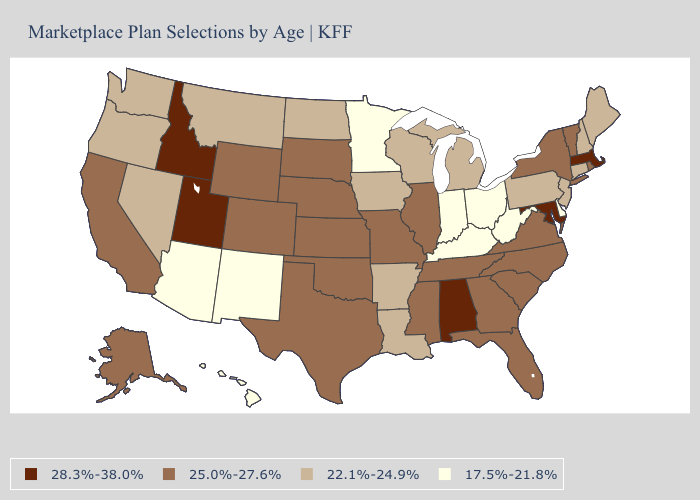Which states hav the highest value in the Northeast?
Write a very short answer. Massachusetts. Which states have the lowest value in the Northeast?
Give a very brief answer. Connecticut, Maine, New Hampshire, New Jersey, Pennsylvania. Name the states that have a value in the range 22.1%-24.9%?
Quick response, please. Arkansas, Connecticut, Iowa, Louisiana, Maine, Michigan, Montana, Nevada, New Hampshire, New Jersey, North Dakota, Oregon, Pennsylvania, Washington, Wisconsin. What is the value of Wisconsin?
Quick response, please. 22.1%-24.9%. What is the lowest value in the USA?
Write a very short answer. 17.5%-21.8%. What is the highest value in the USA?
Answer briefly. 28.3%-38.0%. Among the states that border Rhode Island , which have the highest value?
Quick response, please. Massachusetts. Among the states that border Minnesota , which have the lowest value?
Give a very brief answer. Iowa, North Dakota, Wisconsin. What is the lowest value in the USA?
Write a very short answer. 17.5%-21.8%. Does the map have missing data?
Be succinct. No. What is the value of Nevada?
Be succinct. 22.1%-24.9%. Name the states that have a value in the range 22.1%-24.9%?
Answer briefly. Arkansas, Connecticut, Iowa, Louisiana, Maine, Michigan, Montana, Nevada, New Hampshire, New Jersey, North Dakota, Oregon, Pennsylvania, Washington, Wisconsin. What is the value of Maine?
Keep it brief. 22.1%-24.9%. Which states have the lowest value in the USA?
Keep it brief. Arizona, Delaware, Hawaii, Indiana, Kentucky, Minnesota, New Mexico, Ohio, West Virginia. Name the states that have a value in the range 17.5%-21.8%?
Quick response, please. Arizona, Delaware, Hawaii, Indiana, Kentucky, Minnesota, New Mexico, Ohio, West Virginia. 